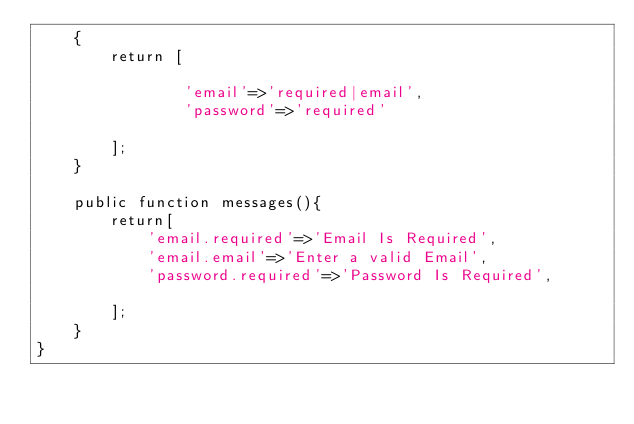Convert code to text. <code><loc_0><loc_0><loc_500><loc_500><_PHP_>    {
        return [
             
                'email'=>'required|email',
                'password'=>'required'
            
        ];
    }

    public function messages(){
        return[
            'email.required'=>'Email Is Required',
            'email.email'=>'Enter a valid Email',
            'password.required'=>'Password Is Required',

        ];
    }
}
</code> 